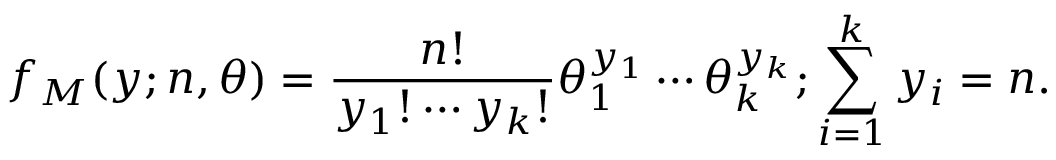<formula> <loc_0><loc_0><loc_500><loc_500>f _ { M } ( \boldsymbol y ; n , \theta ) = \frac { n ! } { y _ { 1 } ! \cdots y _ { k } ! } \theta _ { 1 } ^ { y _ { 1 } } \cdots \theta _ { k } ^ { y _ { k } } ; \sum _ { i = 1 } ^ { k } y _ { i } = n .</formula> 